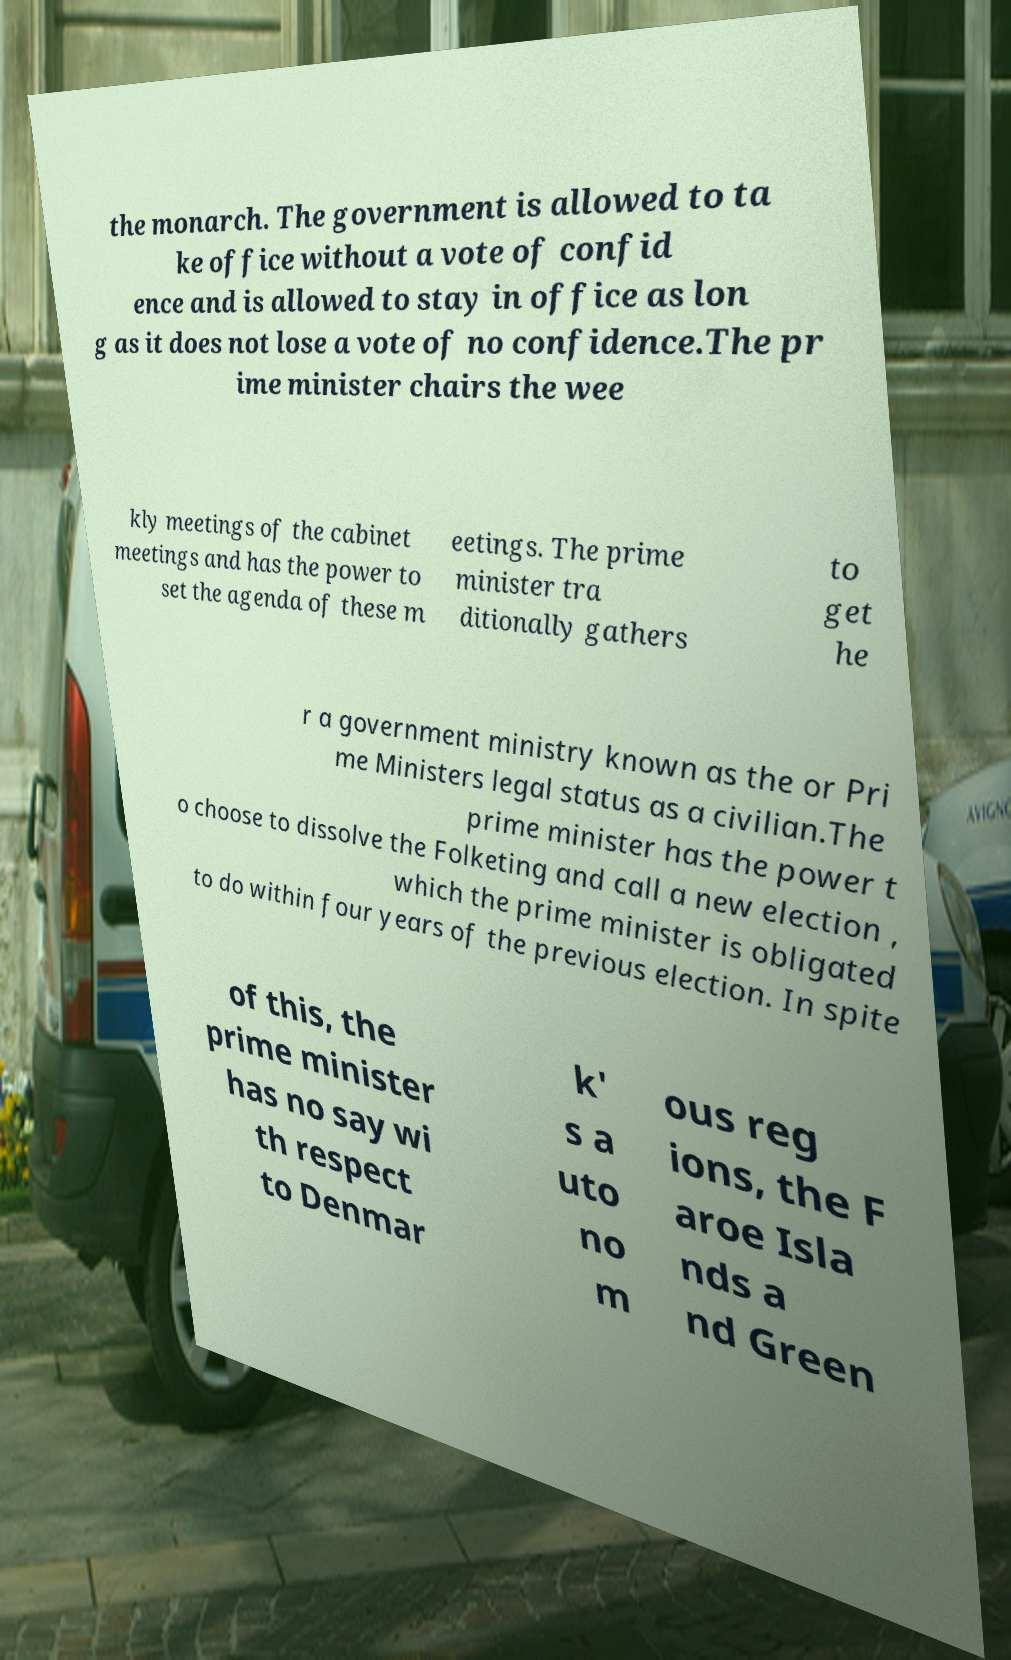Can you read and provide the text displayed in the image?This photo seems to have some interesting text. Can you extract and type it out for me? the monarch. The government is allowed to ta ke office without a vote of confid ence and is allowed to stay in office as lon g as it does not lose a vote of no confidence.The pr ime minister chairs the wee kly meetings of the cabinet meetings and has the power to set the agenda of these m eetings. The prime minister tra ditionally gathers to get he r a government ministry known as the or Pri me Ministers legal status as a civilian.The prime minister has the power t o choose to dissolve the Folketing and call a new election , which the prime minister is obligated to do within four years of the previous election. In spite of this, the prime minister has no say wi th respect to Denmar k' s a uto no m ous reg ions, the F aroe Isla nds a nd Green 